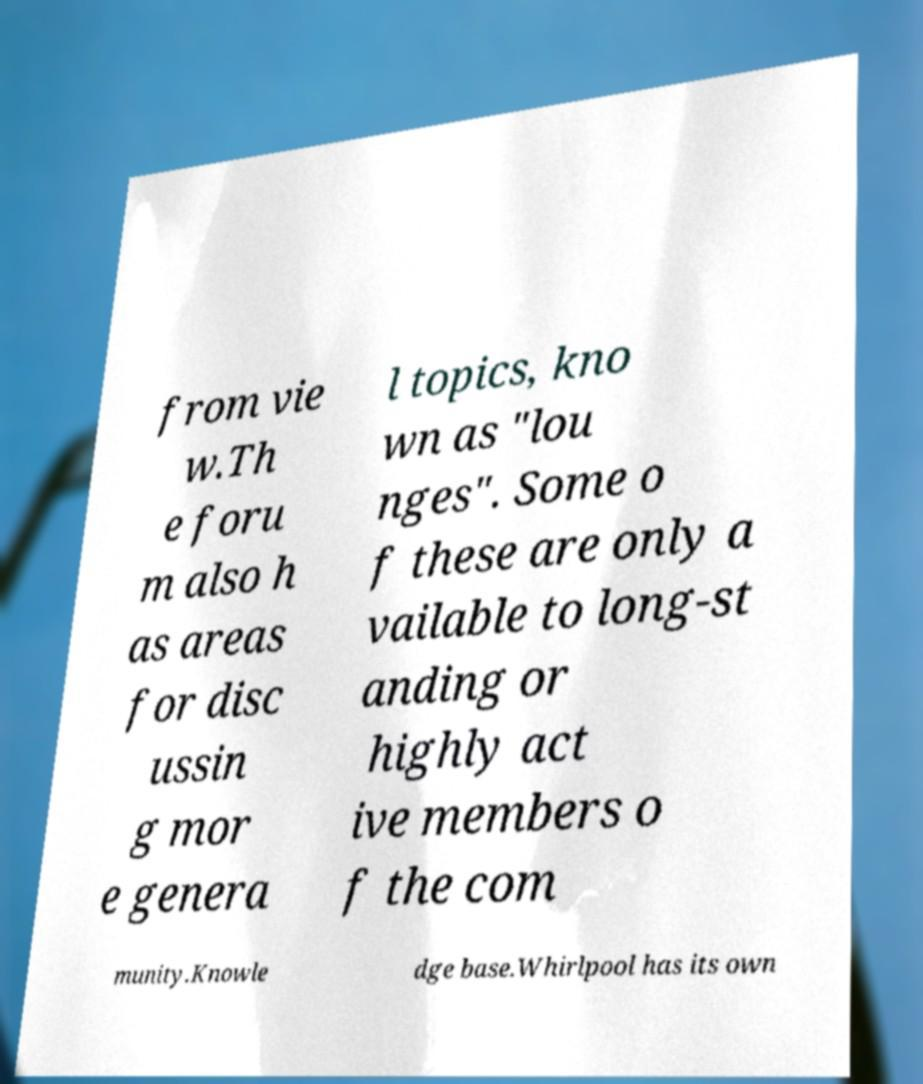Please identify and transcribe the text found in this image. from vie w.Th e foru m also h as areas for disc ussin g mor e genera l topics, kno wn as "lou nges". Some o f these are only a vailable to long-st anding or highly act ive members o f the com munity.Knowle dge base.Whirlpool has its own 